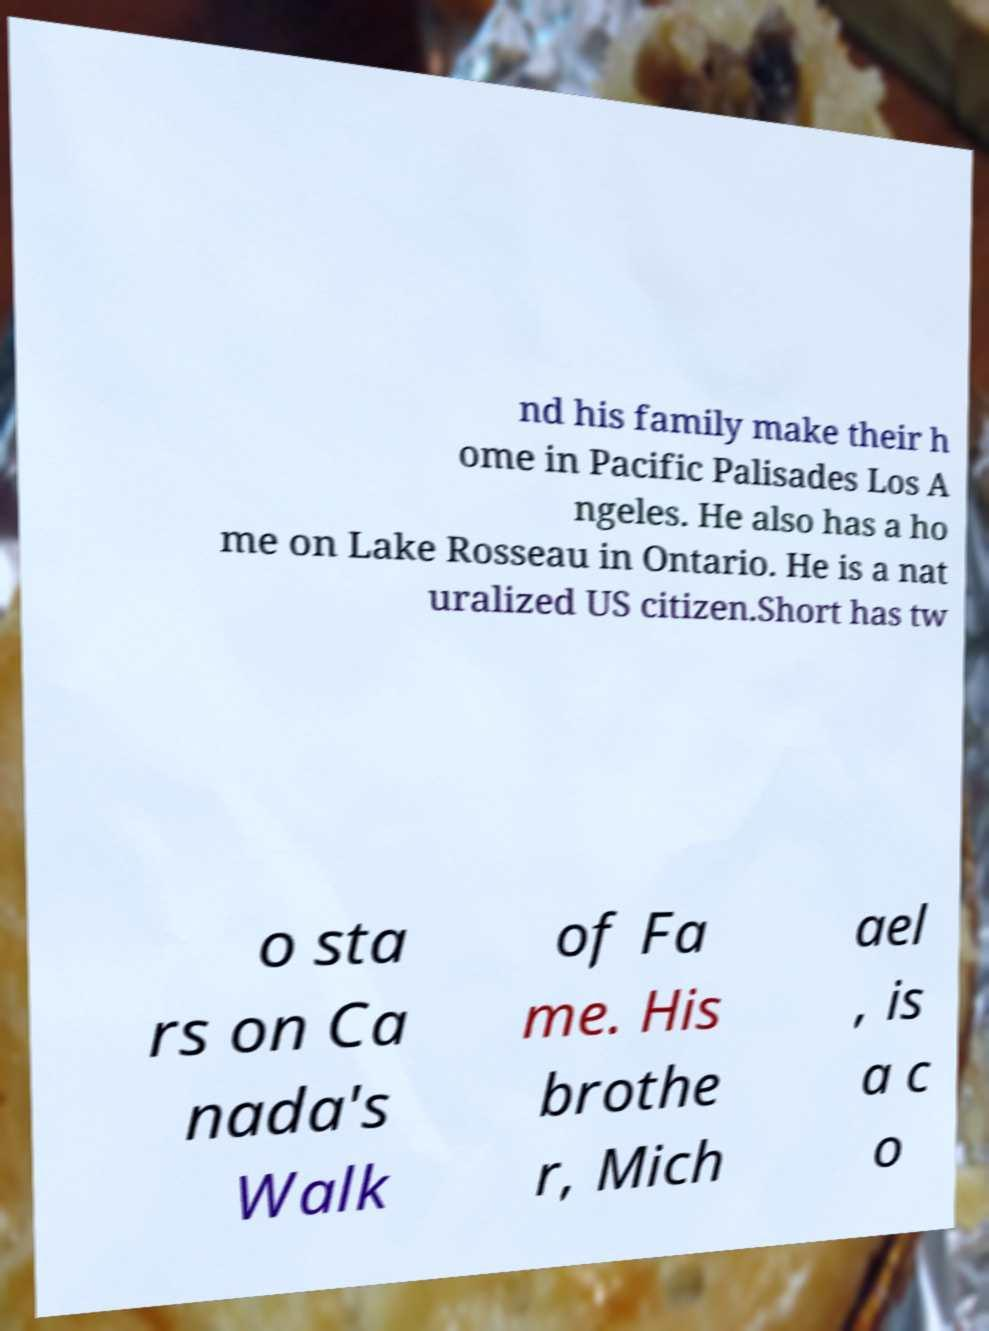Please read and relay the text visible in this image. What does it say? nd his family make their h ome in Pacific Palisades Los A ngeles. He also has a ho me on Lake Rosseau in Ontario. He is a nat uralized US citizen.Short has tw o sta rs on Ca nada's Walk of Fa me. His brothe r, Mich ael , is a c o 